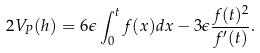Convert formula to latex. <formula><loc_0><loc_0><loc_500><loc_500>2 V _ { P } ( h ) = 6 \epsilon \int _ { 0 } ^ { t } f ( x ) d x - 3 \epsilon \frac { f ( t ) ^ { 2 } } { f ^ { \prime } ( t ) } .</formula> 